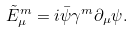<formula> <loc_0><loc_0><loc_500><loc_500>\tilde { E } ^ { m } _ { \mu } = i \bar { \psi } \gamma ^ { m } \partial _ { \mu } \psi .</formula> 